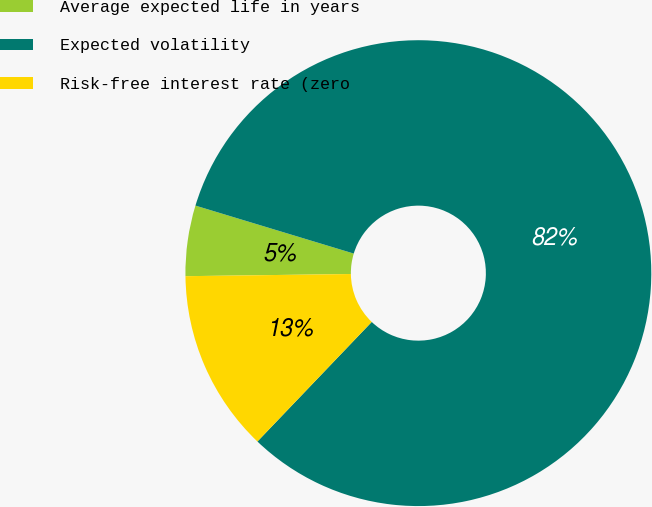Convert chart to OTSL. <chart><loc_0><loc_0><loc_500><loc_500><pie_chart><fcel>Average expected life in years<fcel>Expected volatility<fcel>Risk-free interest rate (zero<nl><fcel>4.89%<fcel>82.46%<fcel>12.65%<nl></chart> 